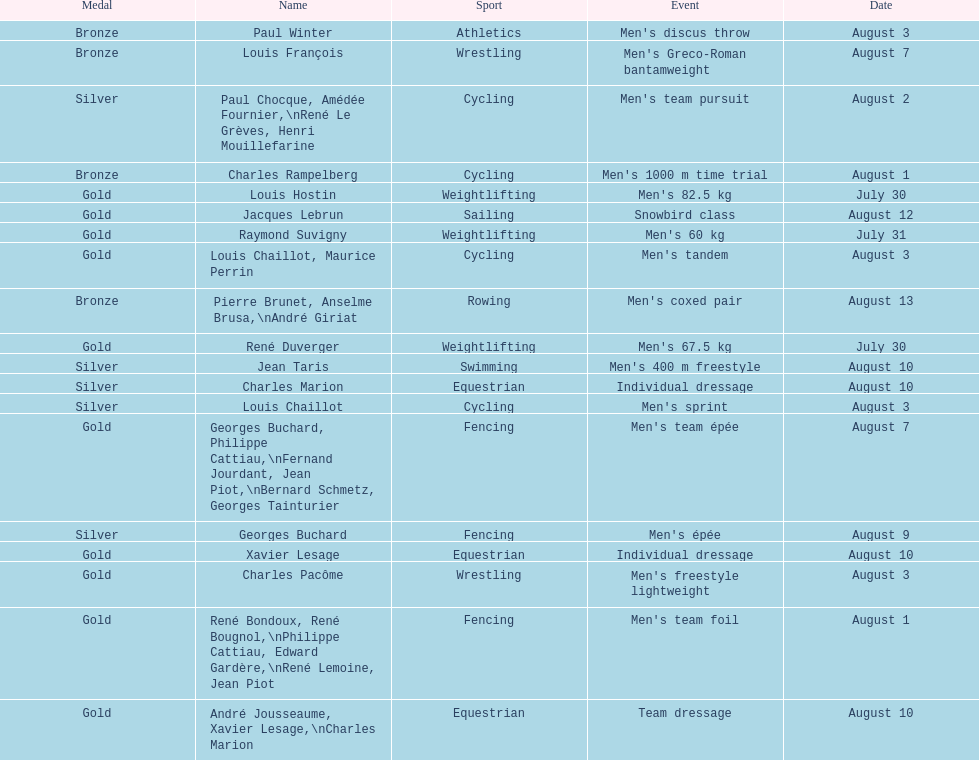How many gold medals did this country win during these olympics? 10. 